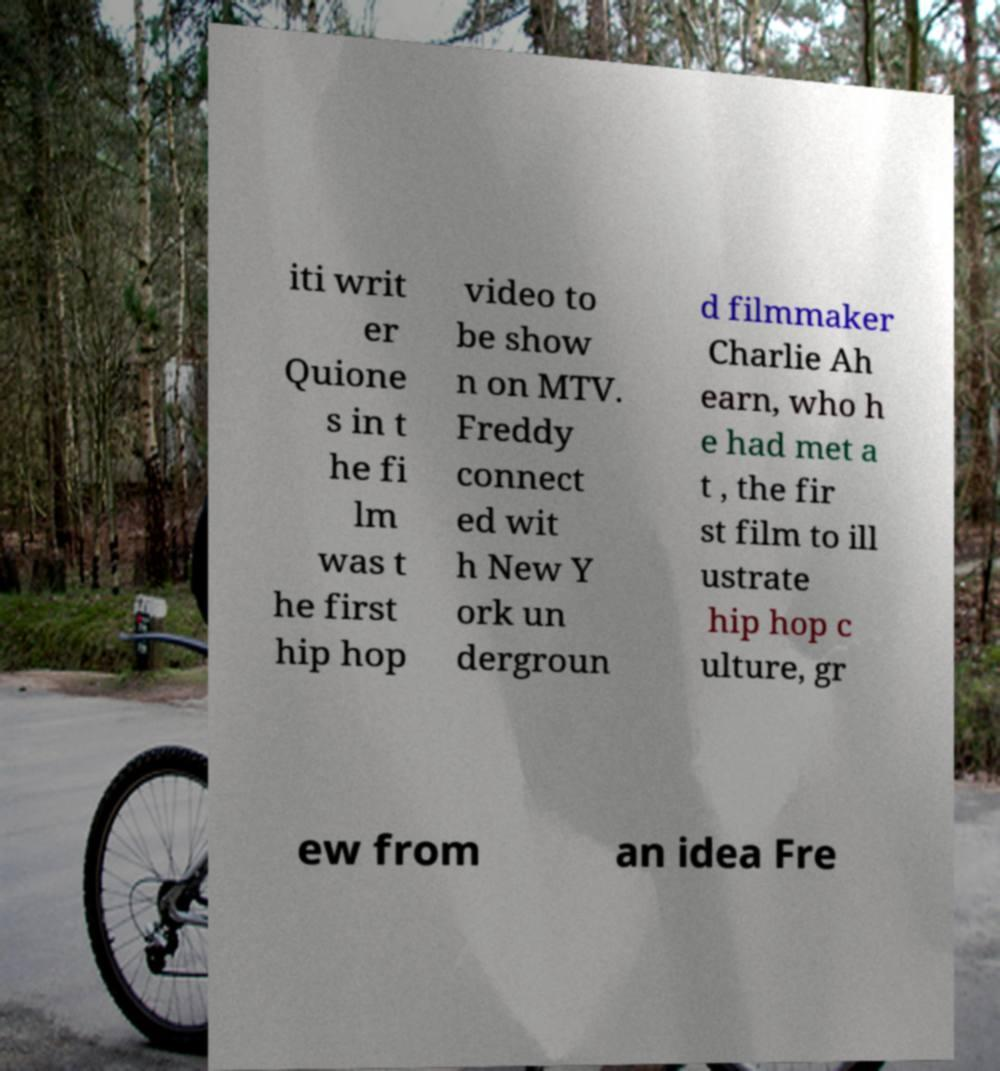I need the written content from this picture converted into text. Can you do that? iti writ er Quione s in t he fi lm was t he first hip hop video to be show n on MTV. Freddy connect ed wit h New Y ork un dergroun d filmmaker Charlie Ah earn, who h e had met a t , the fir st film to ill ustrate hip hop c ulture, gr ew from an idea Fre 